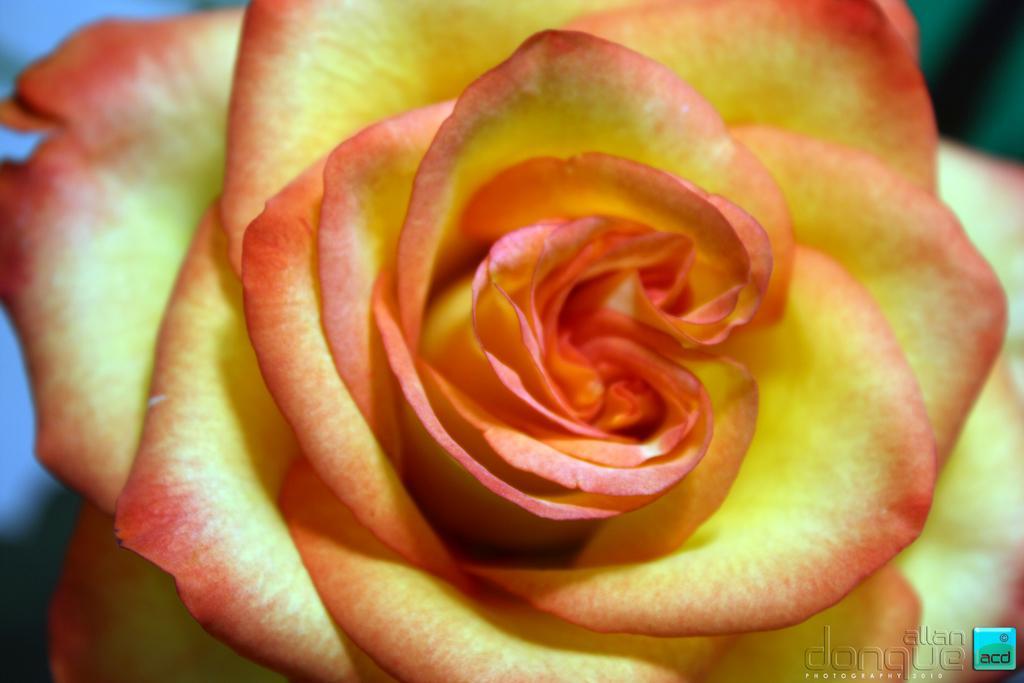Describe this image in one or two sentences. In this picture I can see a rose flower in the middle. There is a watermark in the bottom right hand side. 